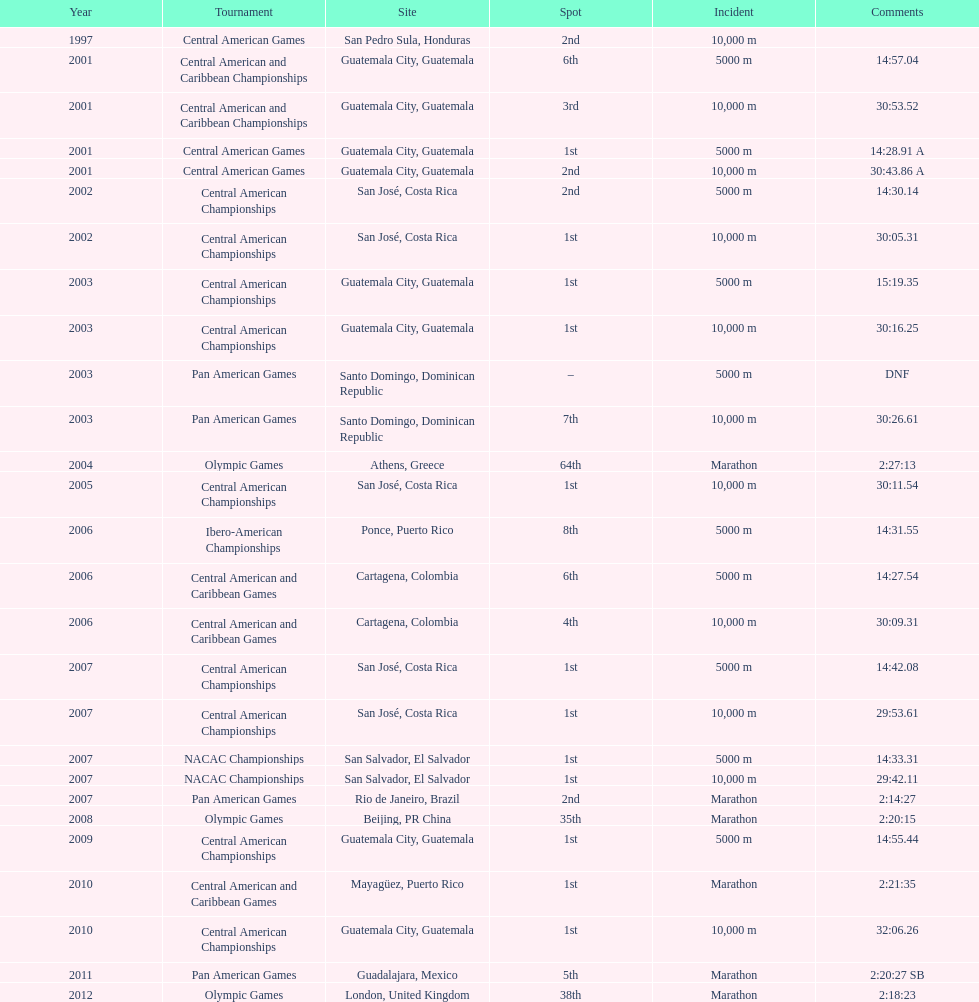What competition did this competitor compete at after participating in the central american games in 2001? Central American Championships. 